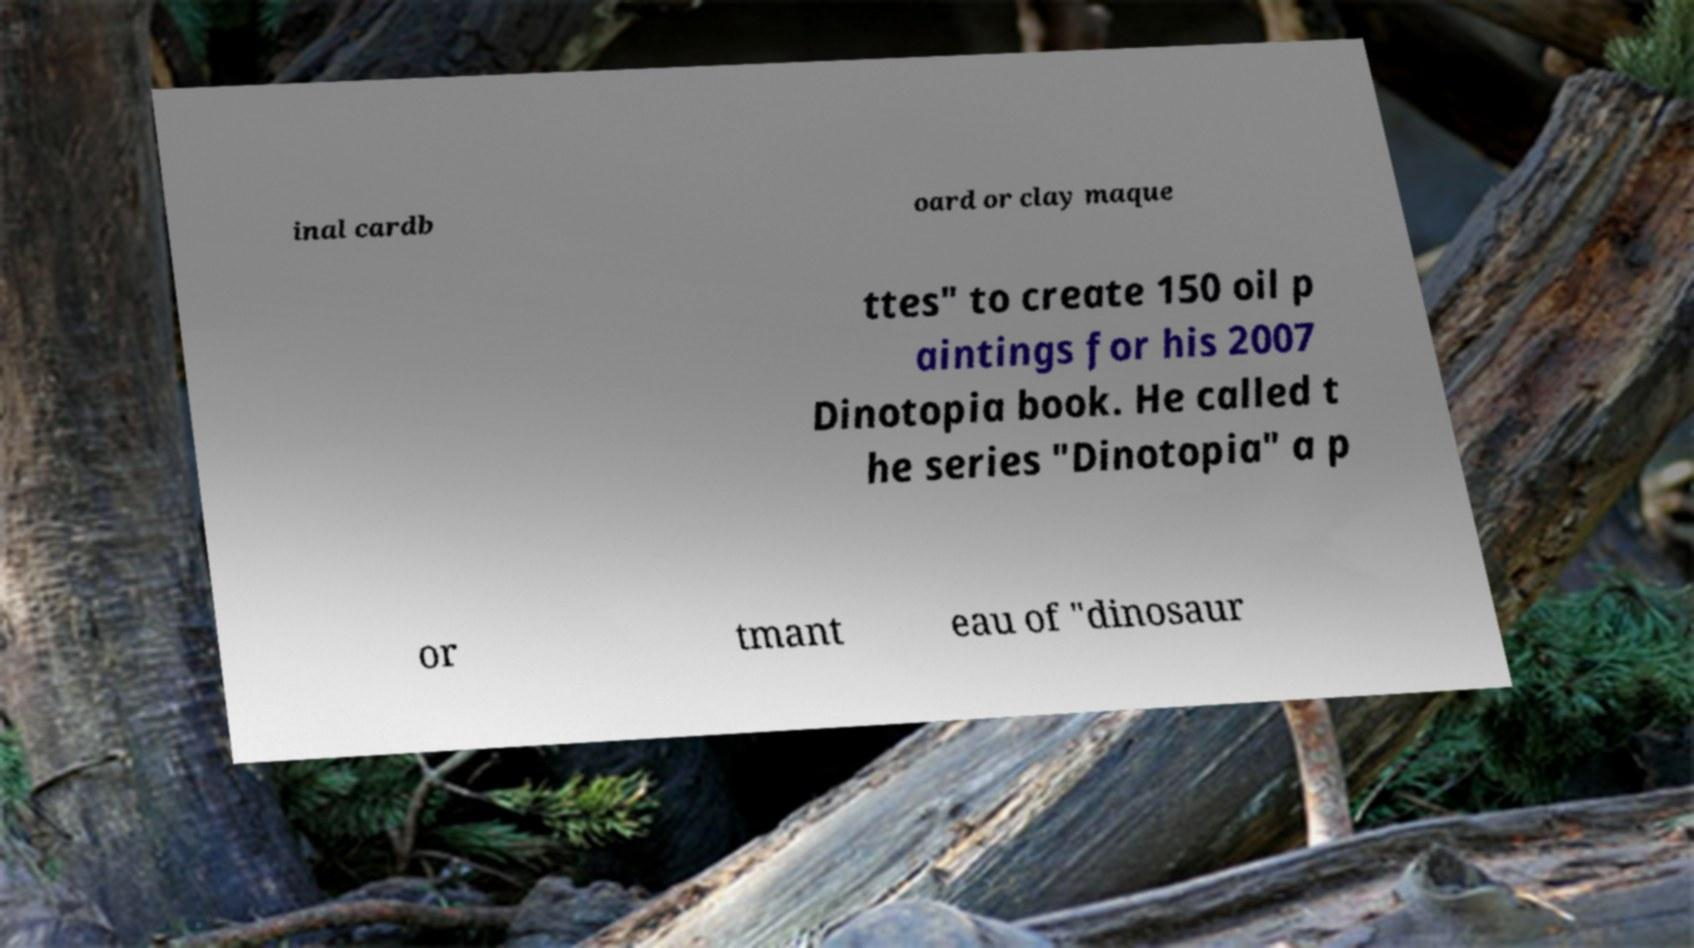Please read and relay the text visible in this image. What does it say? inal cardb oard or clay maque ttes" to create 150 oil p aintings for his 2007 Dinotopia book. He called t he series "Dinotopia" a p or tmant eau of "dinosaur 